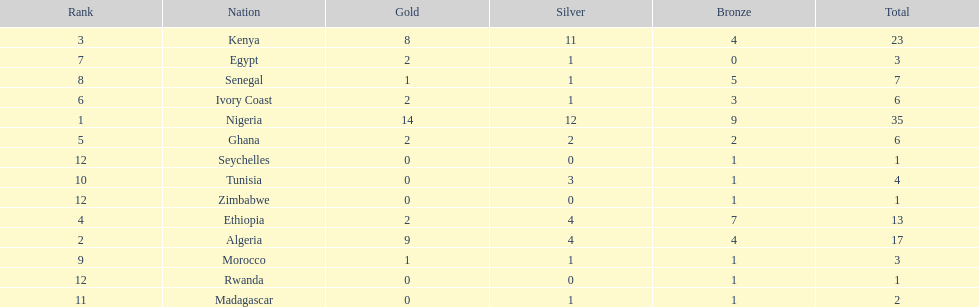The country that won the most medals was? Nigeria. 